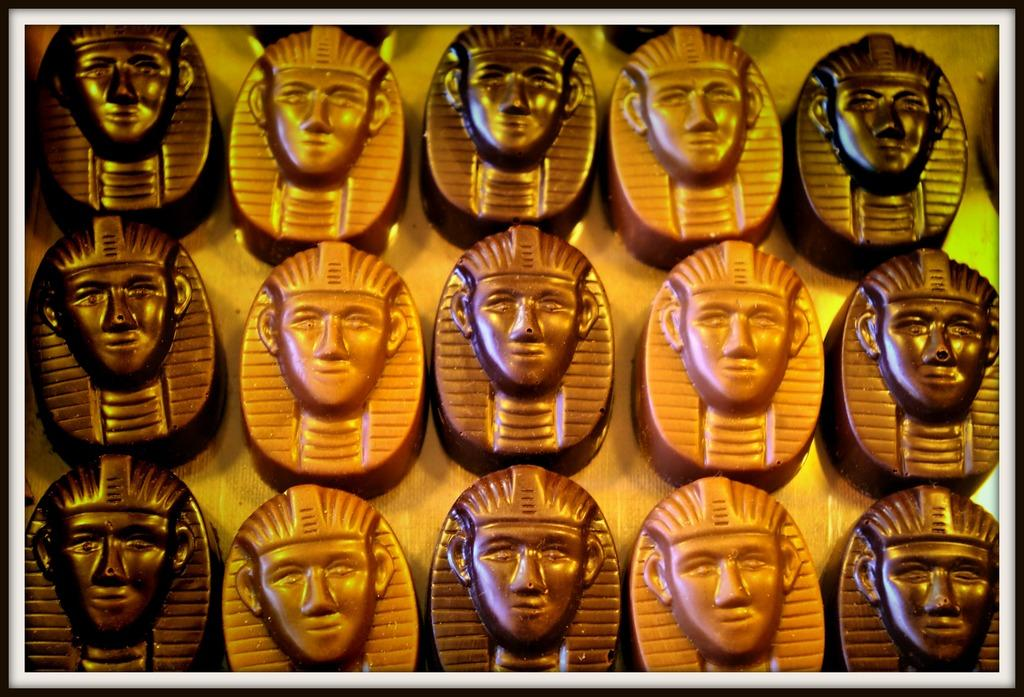What historical figures are depicted in the image? There are Pharaohs in the image. What type of note is being played by the Pharaohs in the image? There is no indication of any musical instruments or notes being played in the image; it simply depicts Pharaohs. 